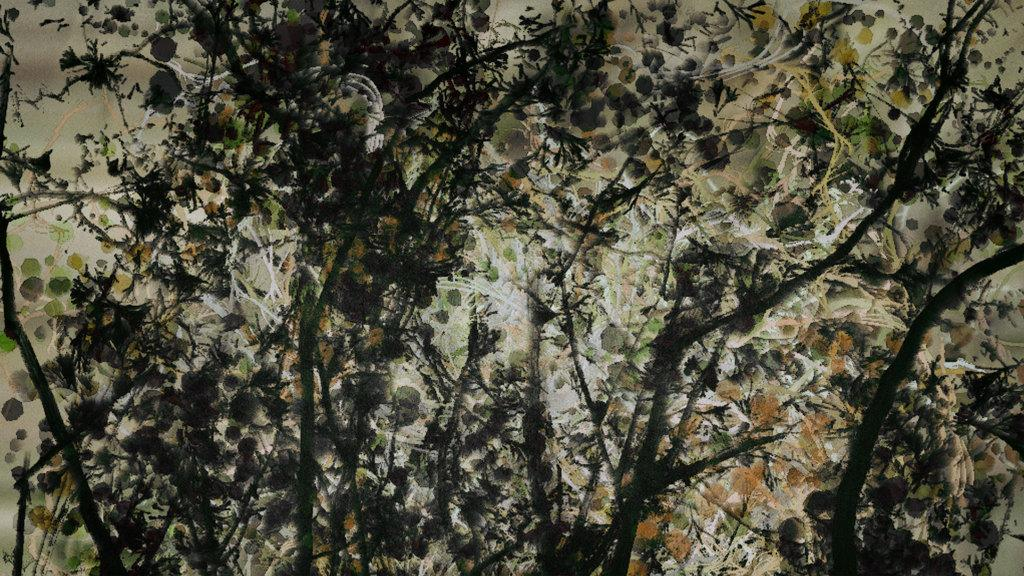What type of artwork is shown in the image? The image is a painting. What is the main subject of the painting? The painting depicts trees. How is the painting displayed? The painting is on a glass surface. How does the artist control the movement of the trees in the painting? The artist does not control the movement of the trees in the painting, as it is a static image. 